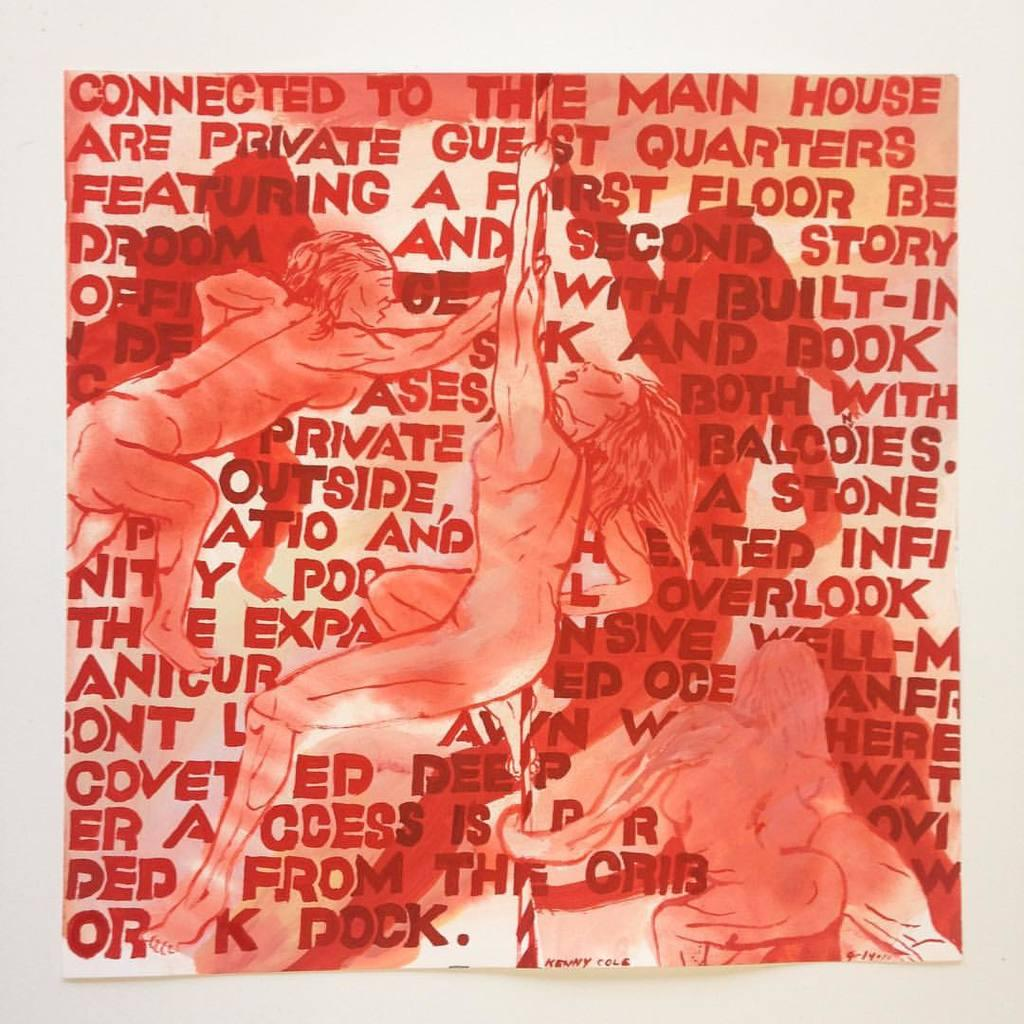What is present on the paper in the image? There is text and pictures on the paper in the image. Can you describe the content of the text on the paper? Unfortunately, the specific content of the text cannot be determined from the image alone. What type of pictures are on the paper? The type of pictures on the paper cannot be determined from the image alone. How many snakes are slithering on the sofa in the image? There are no snakes or sofa present in the image. What is the current temperature in the room where the image was taken? The current temperature cannot be determined from the image alone. 